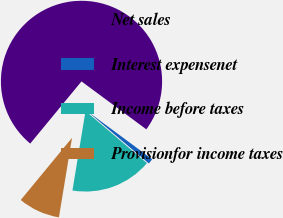<chart> <loc_0><loc_0><loc_500><loc_500><pie_chart><fcel>Net sales<fcel>Interest expensenet<fcel>Income before taxes<fcel>Provisionfor income taxes<nl><fcel>74.15%<fcel>1.07%<fcel>16.39%<fcel>8.38%<nl></chart> 